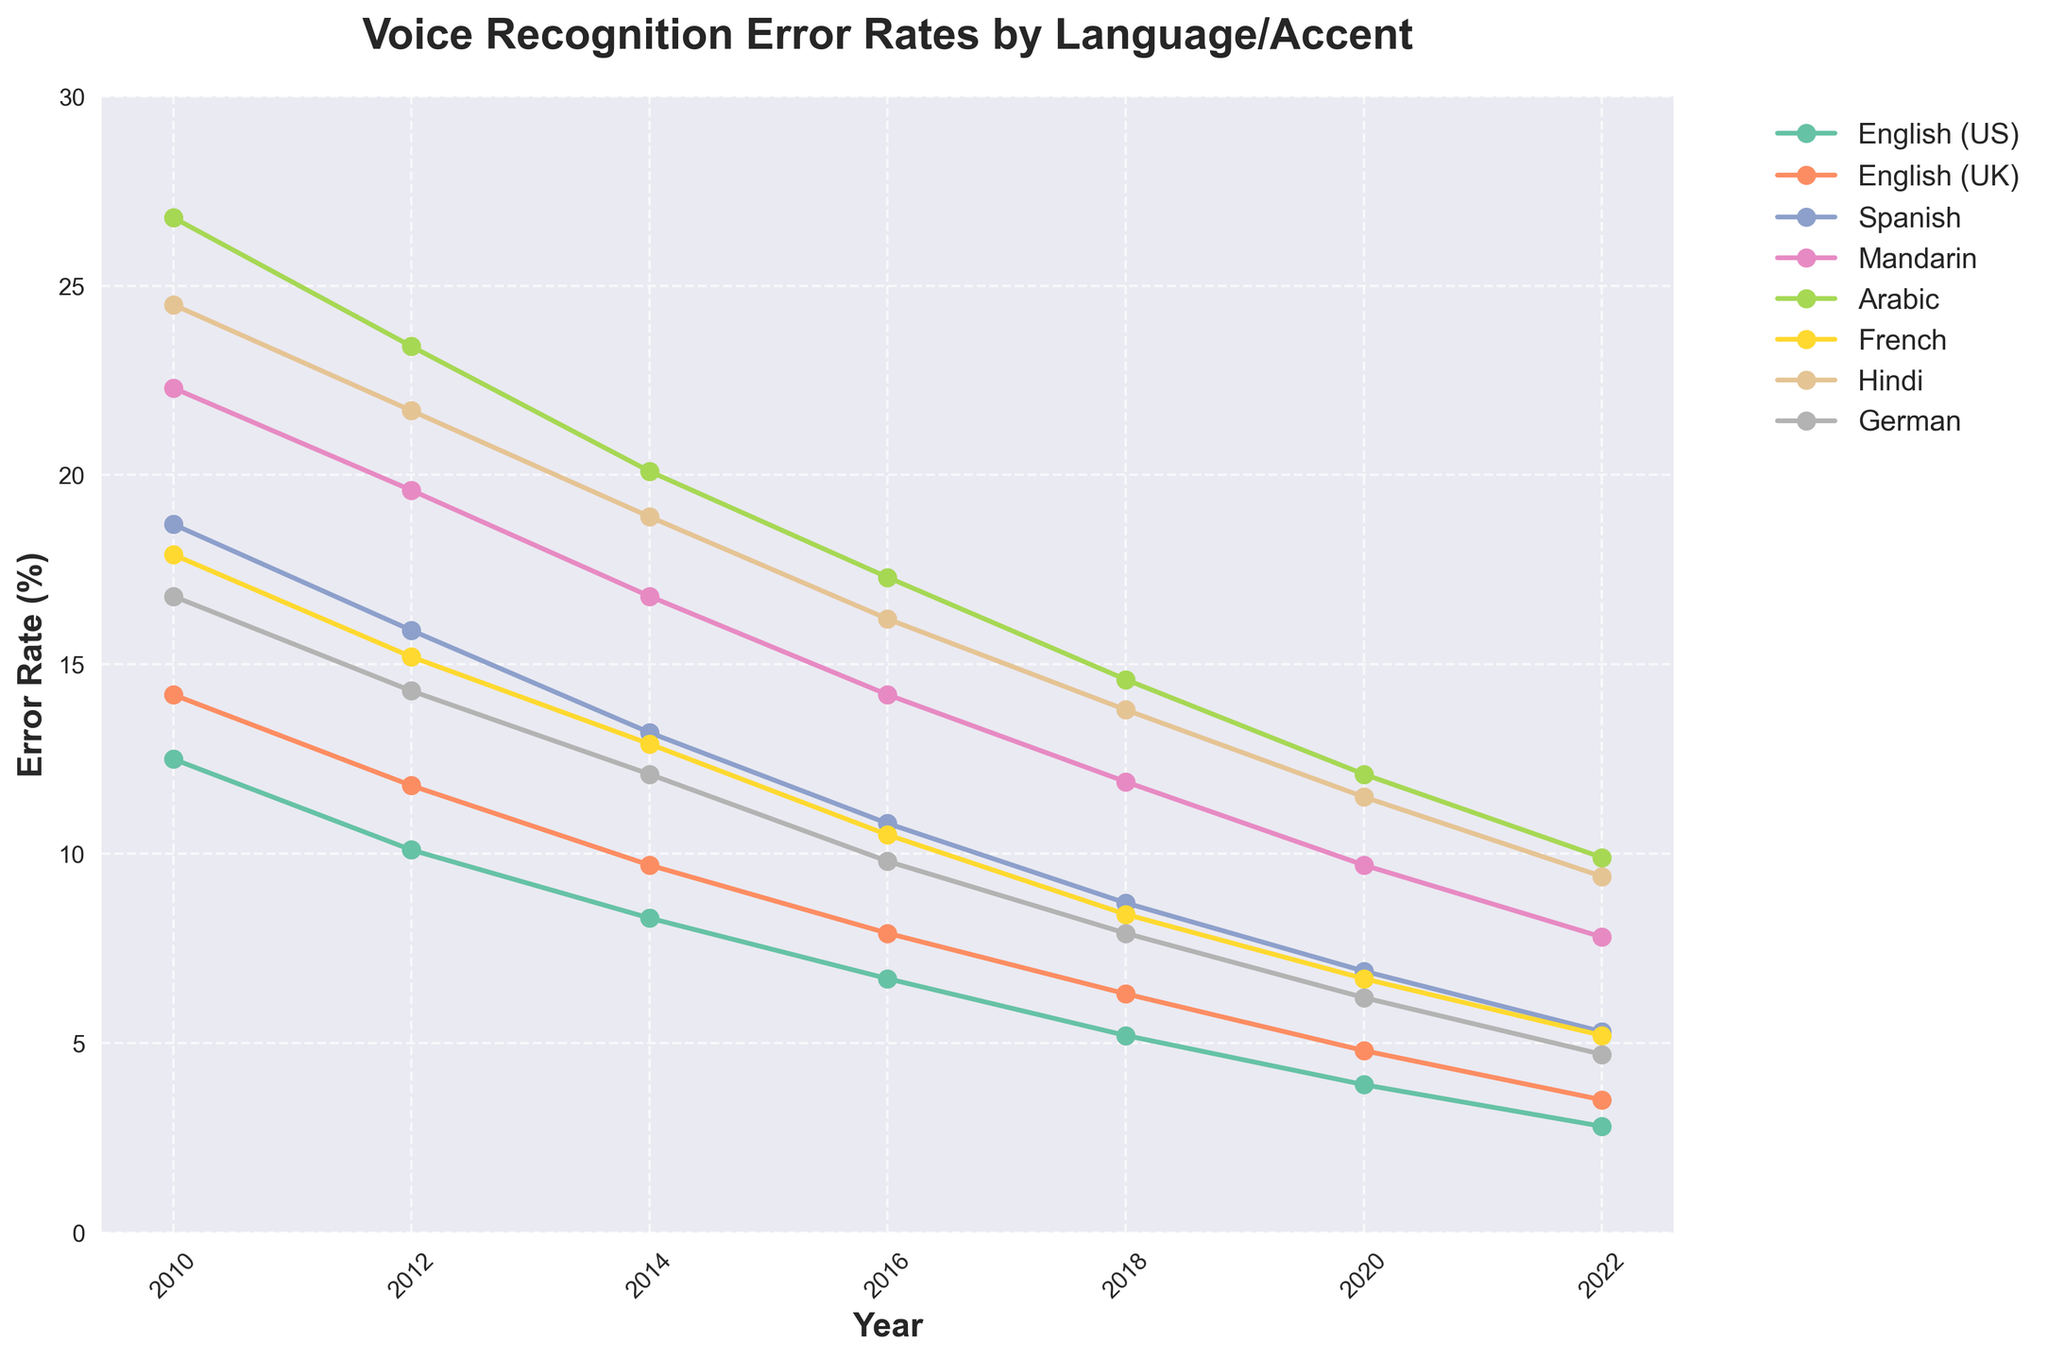Which language saw the greatest reduction in error rate from 2010 to 2022? Note the error rates for all languages in 2010 and 2022. Subtract the 2022 values from the 2010 values for each language to find the reductions. The language with the greatest reduction is Mandarin (22.3% - 7.8% = 14.5%).
Answer: Mandarin Which language had the highest error rate in 2014? Look at the 2014 data and identify the language with the highest percentage. Arabic has the highest error rate of 20.1%.
Answer: Arabic Between English (US) and French, which one had a larger reduction in error rate from 2010 to 2022? Calculate the reduction for English (US) and French from 2010 to 2022: English (US) went from 12.5% to 2.8%, a reduction of 9.7%. French went from 17.9% to 5.2%, a reduction of 12.7%. French had the larger reduction.
Answer: French In which year did Spanish have an error rate closest to 10%? Identify the error rates for Spanish each year and compare them to 10%. In 2016, the error rate for Spanish was 10.8%, which is the closest to 10%.
Answer: 2016 Compare the error rate trends for Hindi and German between 2010 and 2022. What do you notice? Observe the lines representing Hindi and German over the years. Both languages show a decline in error rates, but Hindi starts higher at 24.5% and ends higher at 9.4%, compared to German which starts at 16.8% and ends at 4.7%. Hindi has a consistently higher error rate than German.
Answer: Error rates for both languages decreased, but Hindi consistently had higher rates than German What was the error rate difference between Arabic and French in 2016? Note the error rates for both Arabic and French in 2016. Arabic was at 17.3% and French was at 10.5%. The difference is 17.3% - 10.5% = 6.8%.
Answer: 6.8% Which language had the smallest error rate in 2020, and what was it? Look at the error rates for all languages in 2020. English (US) had the smallest error rate at 3.9%.
Answer: English (US), 3.9% How did the error rate for Mandarin change between 2018 and 2020? Observe the error rates for Mandarin in 2018 (11.9%) and 2020 (9.7%). The change from 11.9% to 9.7% is a reduction of 11.9% - 9.7% = 2.2%.
Answer: Decreased by 2.2% What was the average error rate for Hindi between 2010 and 2022? Sum the error rates for Hindi across all years: 24.5 + 21.7 + 18.9 + 16.2 + 13.8 + 11.5 + 9.4 = 116. Divide by the number of years (7) to get 116 / 7 ≈ 16.57%.
Answer: 16.57% Did any language’s error rate increase at any point between 2010 and 2022? Observe the trend lines for any language between consecutive years. All lines show a consistent decrease in error rates for every language across all years.
Answer: No 